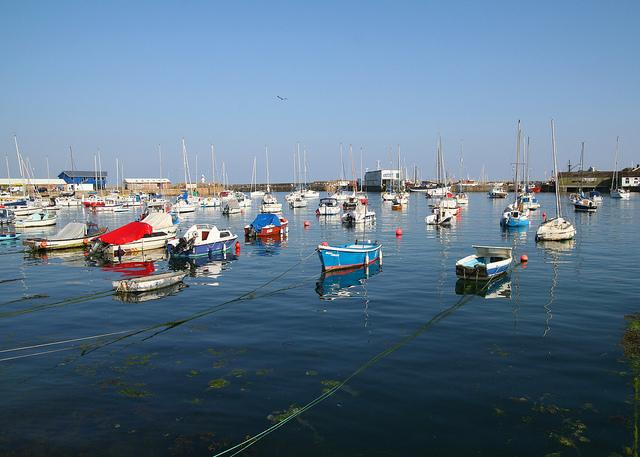These items that are moving can be referred to as being part of what?

Choices:
A) school
B) fleet
C) clowder
D) database fleet 